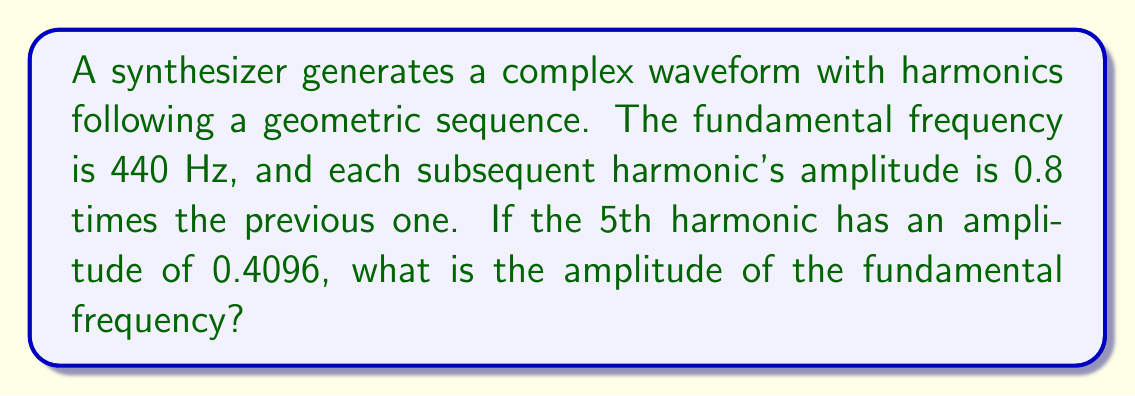What is the answer to this math problem? Let's approach this step-by-step:

1) In a geometric sequence, each term is a constant multiple of the previous term. Let's call this constant $r$. We're told that $r = 0.8$.

2) Let $a_1$ be the amplitude of the fundamental frequency (1st harmonic), which we need to find.

3) The general term of a geometric sequence is given by:

   $a_n = a_1 \cdot r^{n-1}$

4) We're given information about the 5th harmonic. So, $n = 5$ and $a_5 = 0.4096$

5) Let's substitute these into our formula:

   $0.4096 = a_1 \cdot (0.8)^{5-1}$

6) Simplify the right side:

   $0.4096 = a_1 \cdot (0.8)^4$

7) Calculate $(0.8)^4$:

   $0.4096 = a_1 \cdot 0.4096$

8) Now we can solve for $a_1$:

   $a_1 = \frac{0.4096}{0.4096} = 1$

Therefore, the amplitude of the fundamental frequency is 1.
Answer: 1 